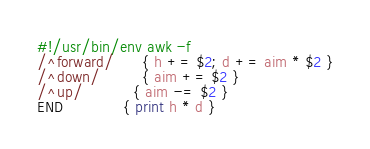<code> <loc_0><loc_0><loc_500><loc_500><_Awk_>#!/usr/bin/env awk -f
/^forward/      { h += $2; d += aim * $2 }
/^down/         { aim += $2 }
/^up/           { aim -= $2 }
END             { print h * d }
</code> 